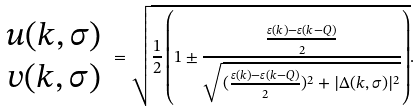Convert formula to latex. <formula><loc_0><loc_0><loc_500><loc_500>\begin{array} { c } u ( { k , \sigma } ) \\ v ( { k , \sigma } ) \end{array} = \sqrt { \frac { 1 } { 2 } \left ( 1 \pm \frac { \frac { \varepsilon ( { k } ) - \varepsilon ( { k - Q } ) } { 2 } } { \sqrt { ( \frac { \varepsilon ( { k } ) - \varepsilon ( { k - Q } ) } { 2 } ) ^ { 2 } + | \Delta ( { k , \sigma } ) | ^ { 2 } } } \right ) } .</formula> 